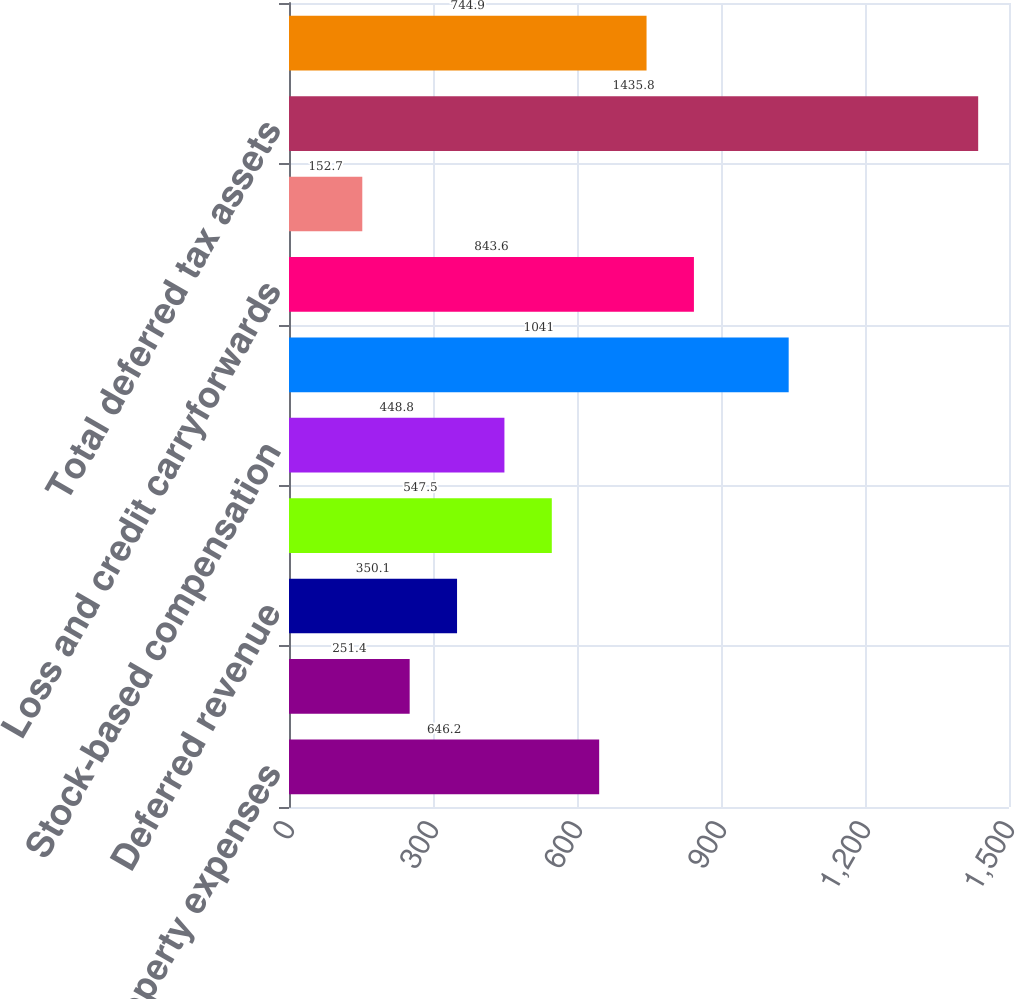Convert chart. <chart><loc_0><loc_0><loc_500><loc_500><bar_chart><fcel>Accrued property expenses<fcel>Other accrued expenses<fcel>Deferred revenue<fcel>Compensation and benefits<fcel>Stock-based compensation<fcel>Goodwill and intangibles<fcel>Loss and credit carryforwards<fcel>Other<fcel>Total deferred tax assets<fcel>Valuation allowance<nl><fcel>646.2<fcel>251.4<fcel>350.1<fcel>547.5<fcel>448.8<fcel>1041<fcel>843.6<fcel>152.7<fcel>1435.8<fcel>744.9<nl></chart> 